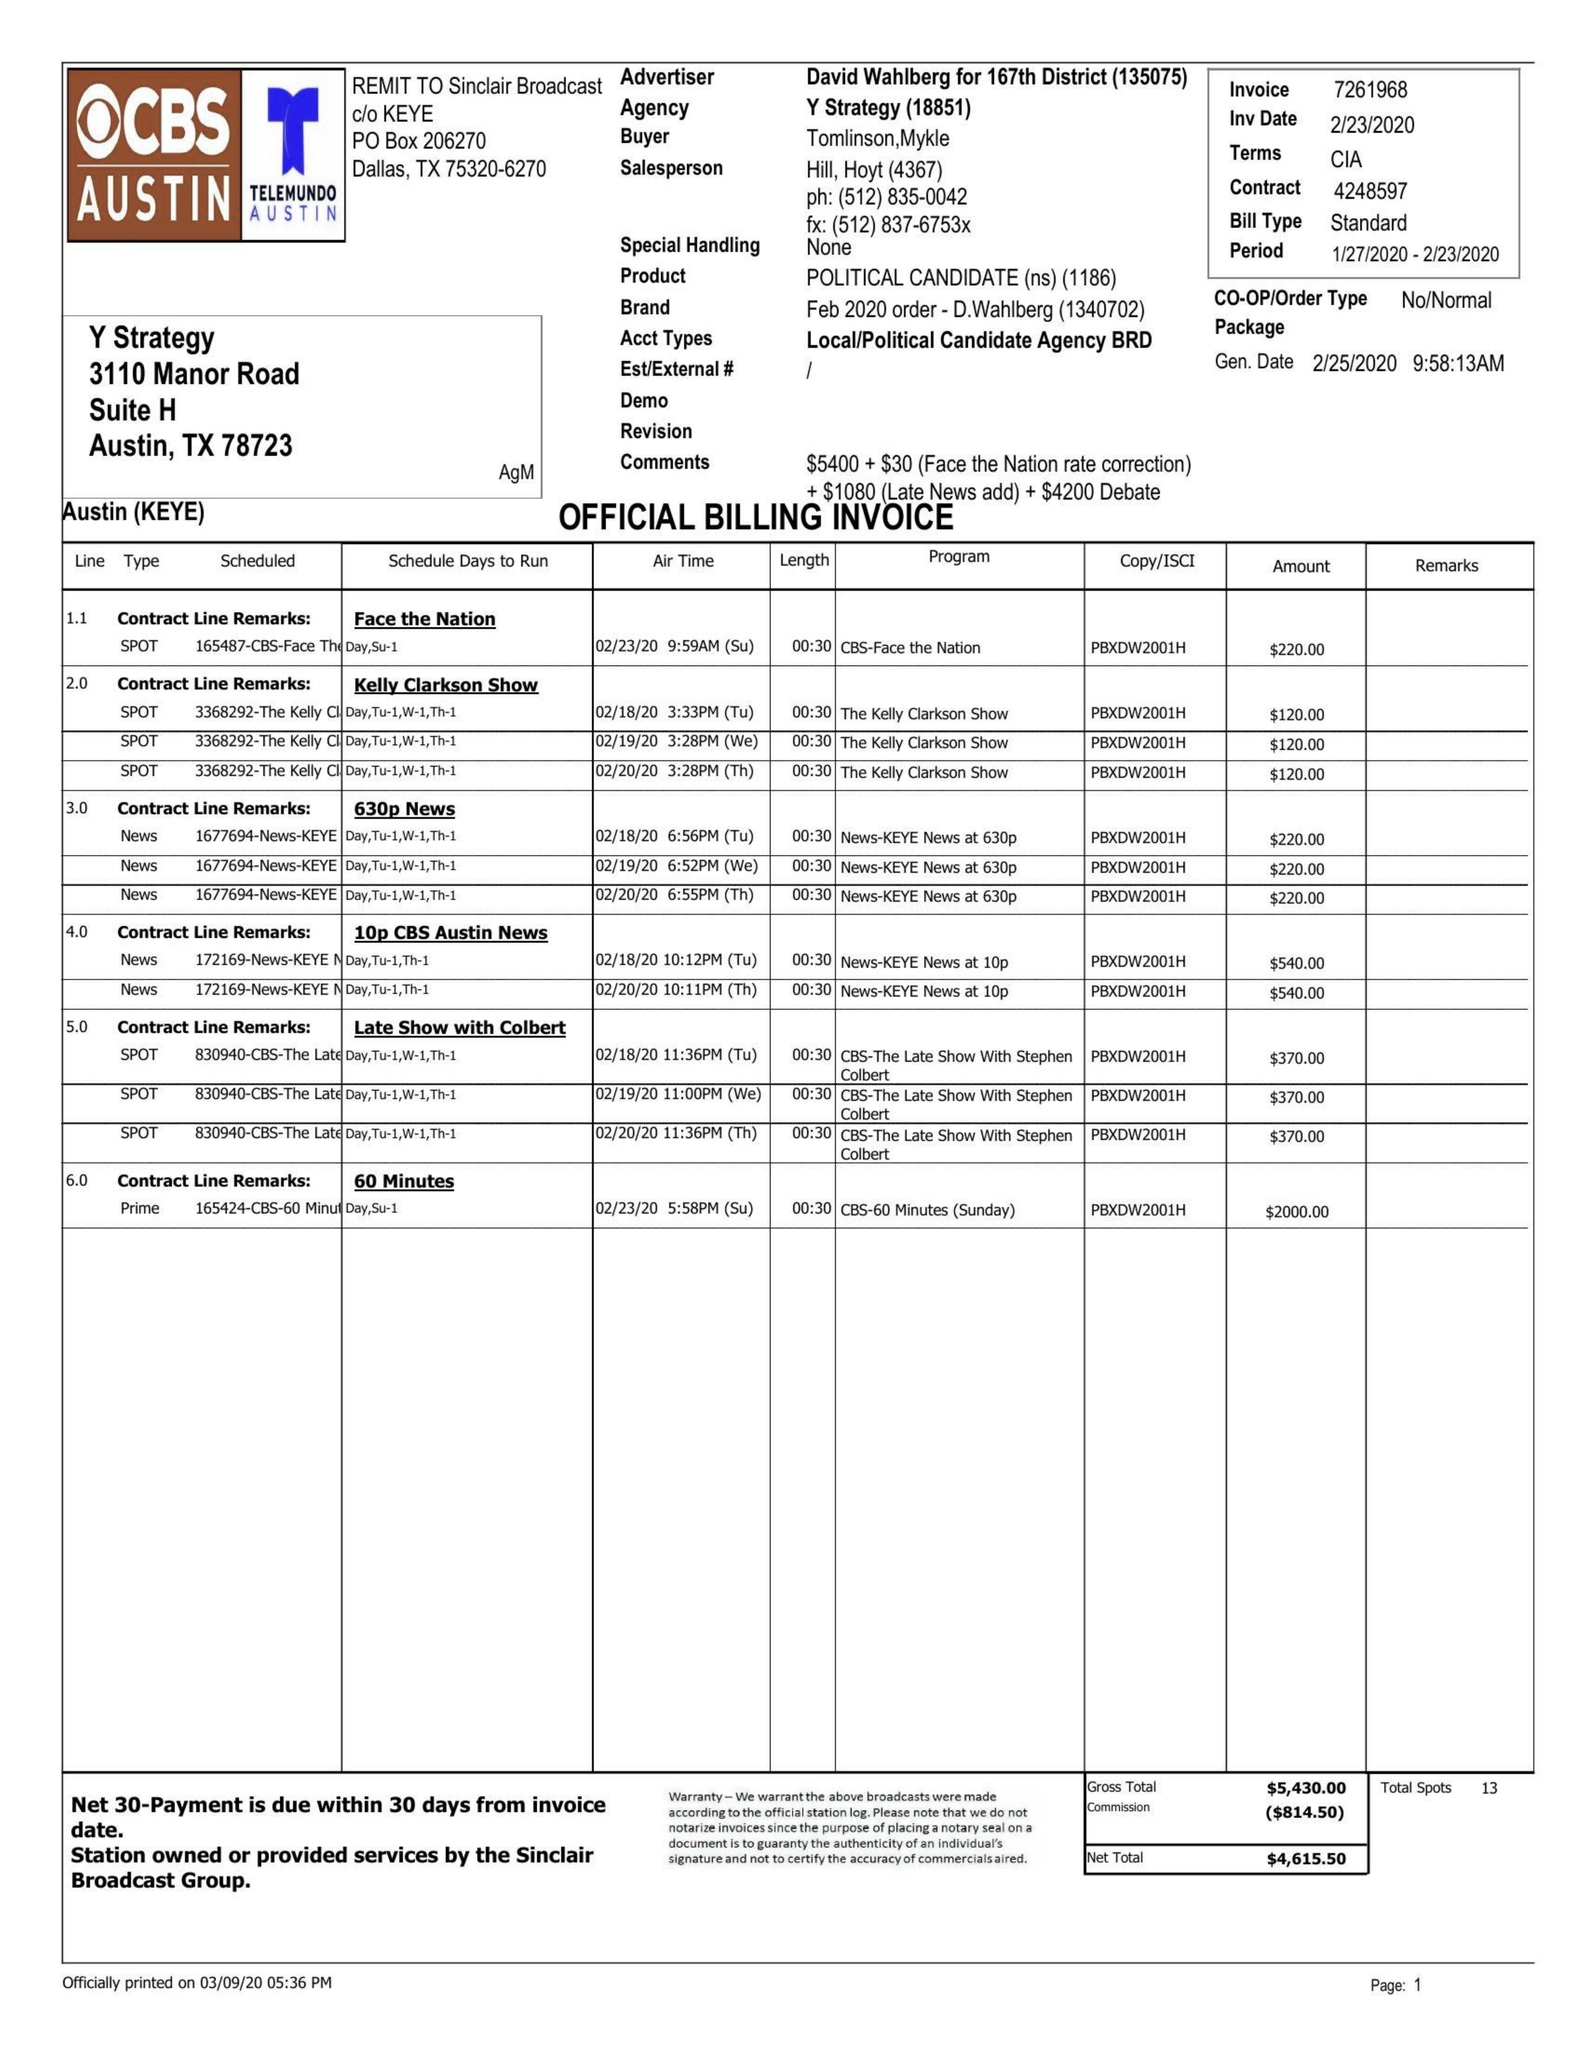What is the value for the gross_amount?
Answer the question using a single word or phrase. 5430.00 